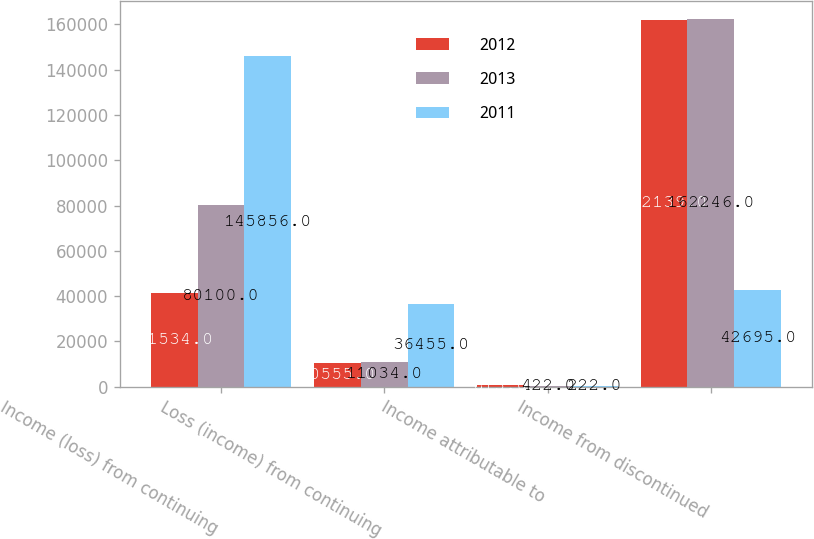Convert chart to OTSL. <chart><loc_0><loc_0><loc_500><loc_500><stacked_bar_chart><ecel><fcel>Income (loss) from continuing<fcel>Loss (income) from continuing<fcel>Income attributable to<fcel>Income from discontinued<nl><fcel>2012<fcel>41534<fcel>10555<fcel>813<fcel>162139<nl><fcel>2013<fcel>80100<fcel>11034<fcel>422<fcel>162246<nl><fcel>2011<fcel>145856<fcel>36455<fcel>222<fcel>42695<nl></chart> 